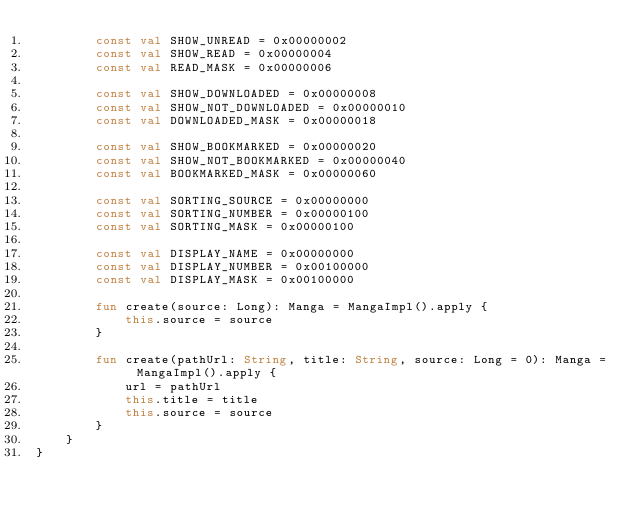Convert code to text. <code><loc_0><loc_0><loc_500><loc_500><_Kotlin_>        const val SHOW_UNREAD = 0x00000002
        const val SHOW_READ = 0x00000004
        const val READ_MASK = 0x00000006

        const val SHOW_DOWNLOADED = 0x00000008
        const val SHOW_NOT_DOWNLOADED = 0x00000010
        const val DOWNLOADED_MASK = 0x00000018

        const val SHOW_BOOKMARKED = 0x00000020
        const val SHOW_NOT_BOOKMARKED = 0x00000040
        const val BOOKMARKED_MASK = 0x00000060

        const val SORTING_SOURCE = 0x00000000
        const val SORTING_NUMBER = 0x00000100
        const val SORTING_MASK = 0x00000100

        const val DISPLAY_NAME = 0x00000000
        const val DISPLAY_NUMBER = 0x00100000
        const val DISPLAY_MASK = 0x00100000

        fun create(source: Long): Manga = MangaImpl().apply {
            this.source = source
        }

        fun create(pathUrl: String, title: String, source: Long = 0): Manga = MangaImpl().apply {
            url = pathUrl
            this.title = title
            this.source = source
        }
    }
}
</code> 